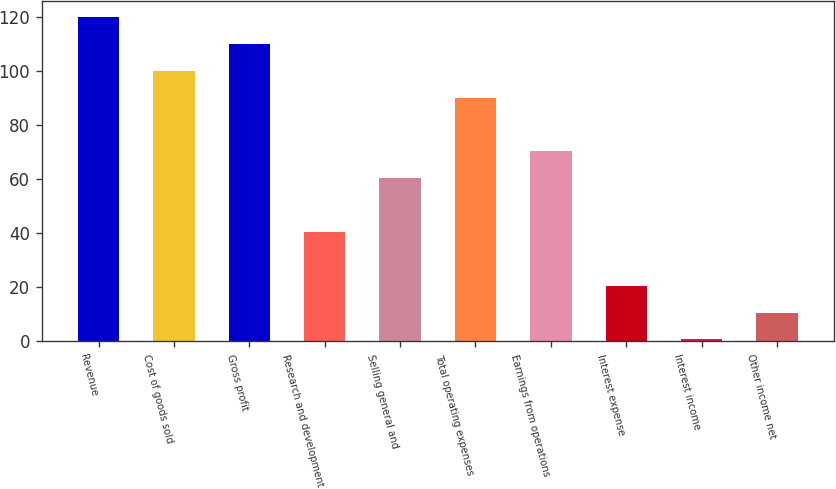<chart> <loc_0><loc_0><loc_500><loc_500><bar_chart><fcel>Revenue<fcel>Cost of goods sold<fcel>Gross profit<fcel>Research and development<fcel>Selling general and<fcel>Total operating expenses<fcel>Earnings from operations<fcel>Interest expense<fcel>Interest income<fcel>Other income net<nl><fcel>119.86<fcel>100<fcel>109.93<fcel>40.42<fcel>60.28<fcel>90.07<fcel>70.21<fcel>20.56<fcel>0.7<fcel>10.63<nl></chart> 